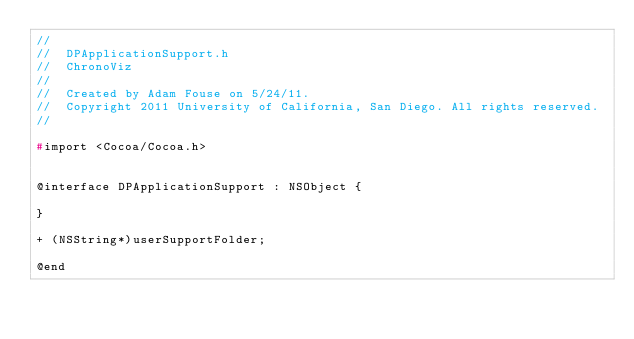<code> <loc_0><loc_0><loc_500><loc_500><_C_>//
//  DPApplicationSupport.h
//  ChronoViz
//
//  Created by Adam Fouse on 5/24/11.
//  Copyright 2011 University of California, San Diego. All rights reserved.
//

#import <Cocoa/Cocoa.h>


@interface DPApplicationSupport : NSObject {

}

+ (NSString*)userSupportFolder;

@end
</code> 